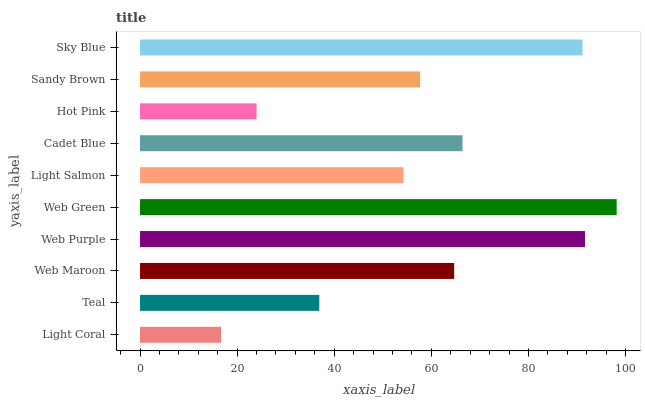Is Light Coral the minimum?
Answer yes or no. Yes. Is Web Green the maximum?
Answer yes or no. Yes. Is Teal the minimum?
Answer yes or no. No. Is Teal the maximum?
Answer yes or no. No. Is Teal greater than Light Coral?
Answer yes or no. Yes. Is Light Coral less than Teal?
Answer yes or no. Yes. Is Light Coral greater than Teal?
Answer yes or no. No. Is Teal less than Light Coral?
Answer yes or no. No. Is Web Maroon the high median?
Answer yes or no. Yes. Is Sandy Brown the low median?
Answer yes or no. Yes. Is Sky Blue the high median?
Answer yes or no. No. Is Web Purple the low median?
Answer yes or no. No. 